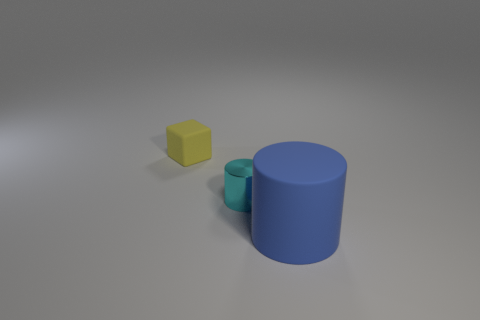Add 2 tiny green metal cylinders. How many objects exist? 5 Subtract all cubes. How many objects are left? 2 Subtract all gray shiny blocks. Subtract all tiny yellow cubes. How many objects are left? 2 Add 2 shiny things. How many shiny things are left? 3 Add 3 tiny yellow matte things. How many tiny yellow matte things exist? 4 Subtract 1 blue cylinders. How many objects are left? 2 